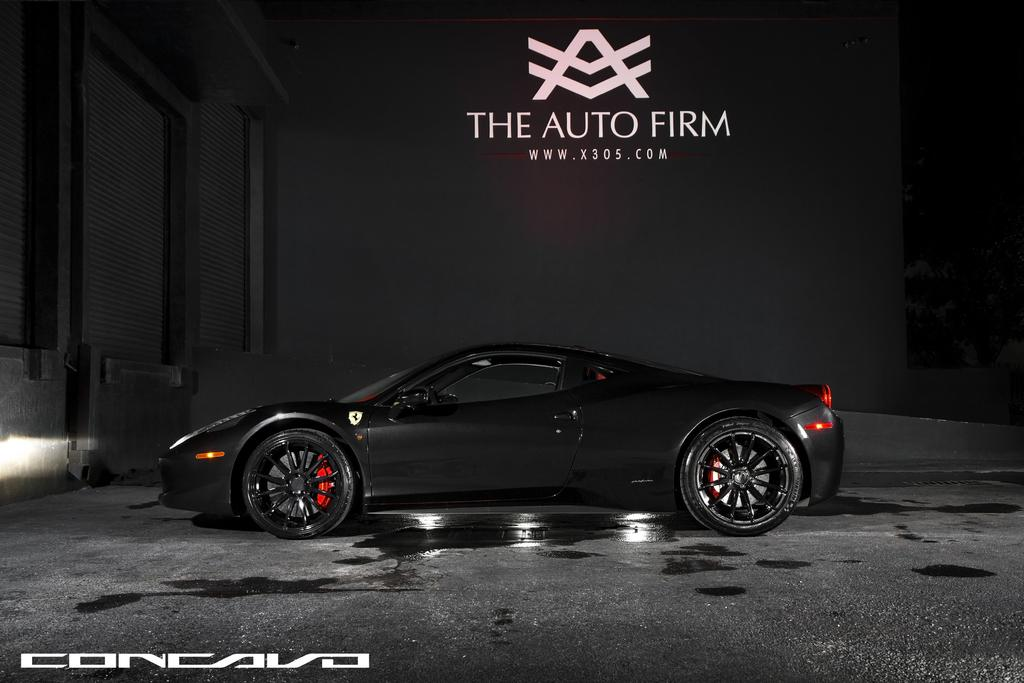What can be seen in the bottom left corner of the image? There is a watermark in the bottom left of the image. What is located in the background of the image? There is a vehicle parked in the background of the image, and it is on the floor. What is on the wall in the background of the image? There is a hoarding on the wall in the background of the image. What is the color of the background in the image? The background color is gray. What type of meal is being prepared in the wilderness in the image? There is no wilderness or meal preparation present in the image. How does the temper of the person in the image change throughout the day? There is no person present in the image, so their temper cannot be assessed. 